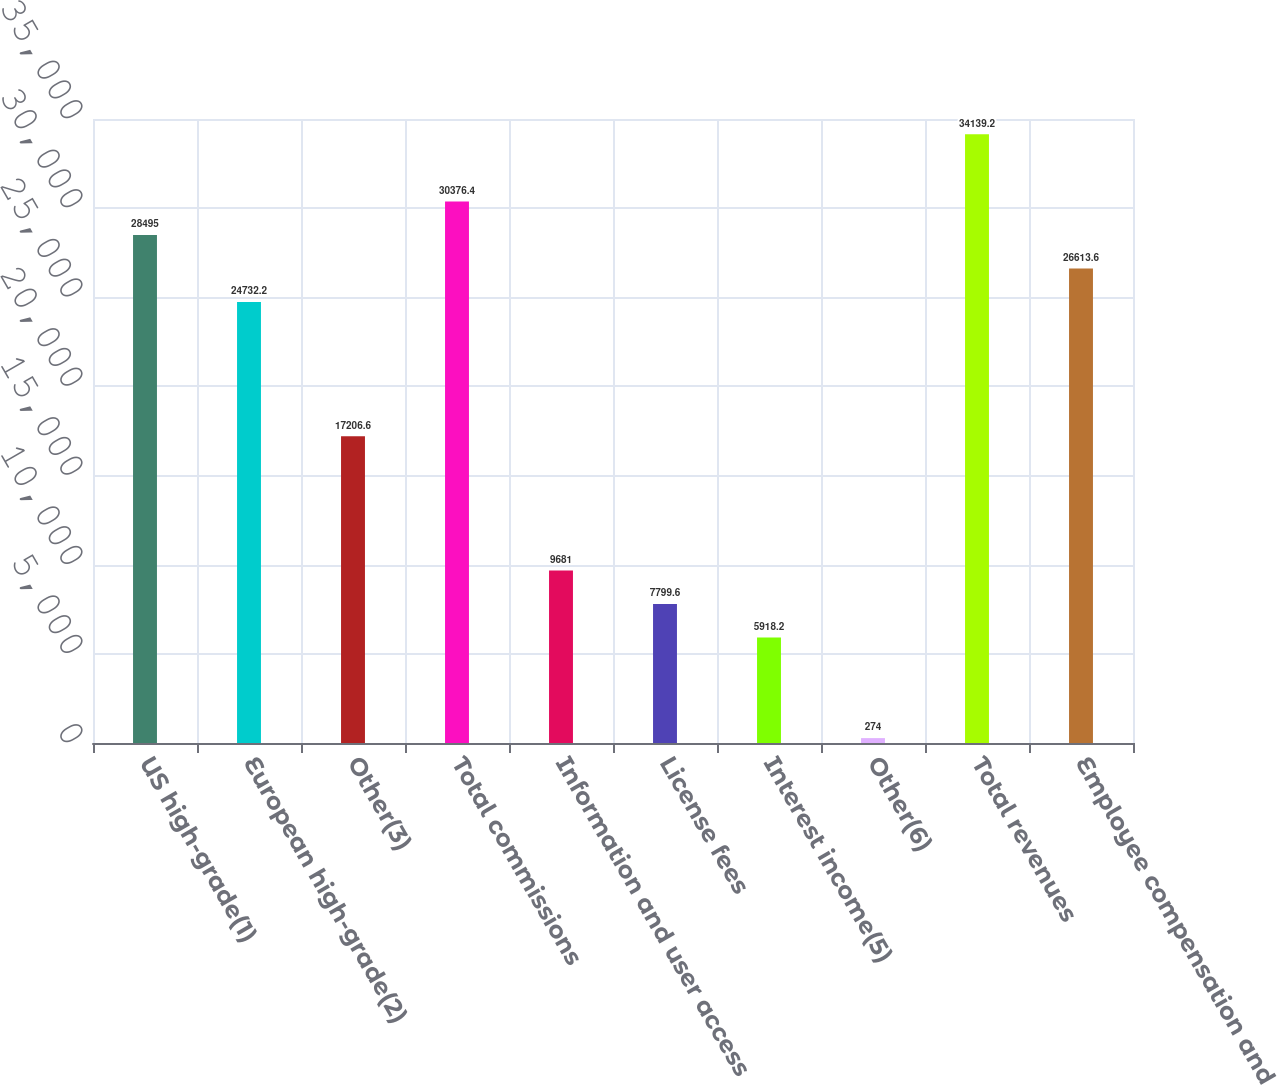Convert chart to OTSL. <chart><loc_0><loc_0><loc_500><loc_500><bar_chart><fcel>US high-grade(1)<fcel>European high-grade(2)<fcel>Other(3)<fcel>Total commissions<fcel>Information and user access<fcel>License fees<fcel>Interest income(5)<fcel>Other(6)<fcel>Total revenues<fcel>Employee compensation and<nl><fcel>28495<fcel>24732.2<fcel>17206.6<fcel>30376.4<fcel>9681<fcel>7799.6<fcel>5918.2<fcel>274<fcel>34139.2<fcel>26613.6<nl></chart> 